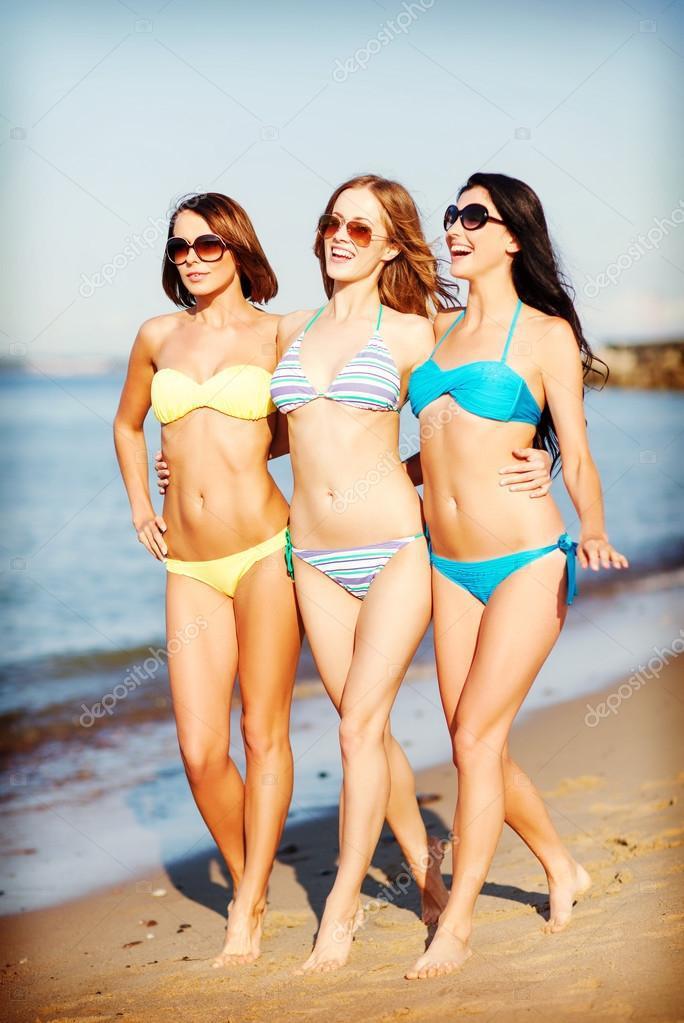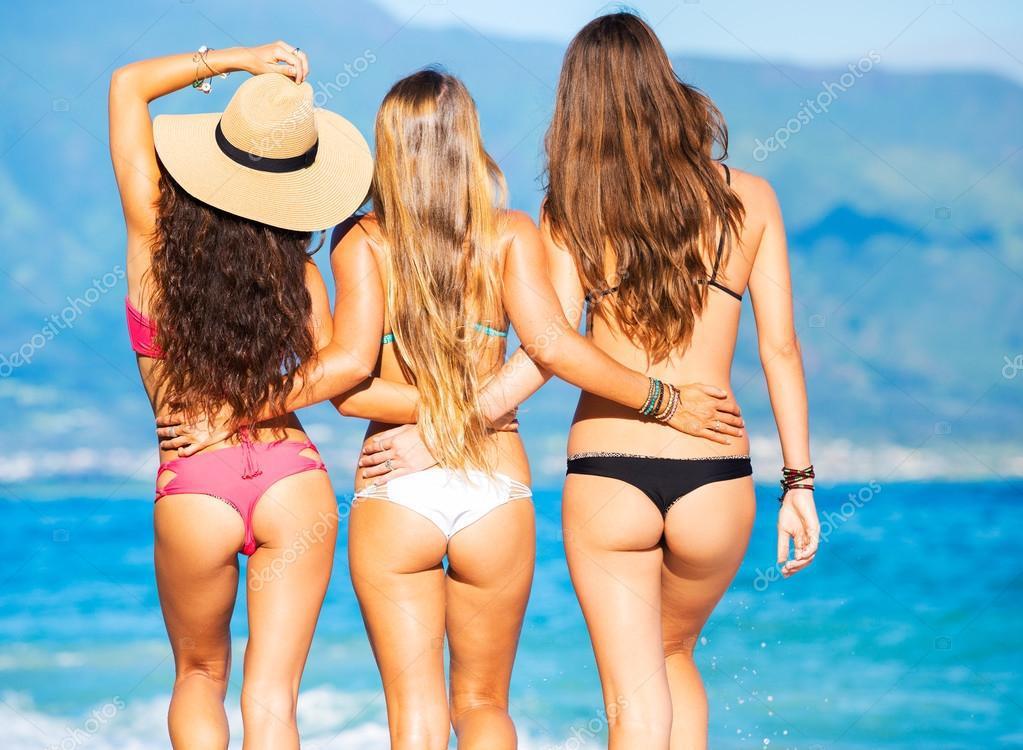The first image is the image on the left, the second image is the image on the right. For the images displayed, is the sentence "There is a total of six women in bikinis." factually correct? Answer yes or no. Yes. The first image is the image on the left, the second image is the image on the right. For the images shown, is this caption "Three forward-facing bikini models are in the left image, and three rear-facing bikini models are in the right image." true? Answer yes or no. Yes. 